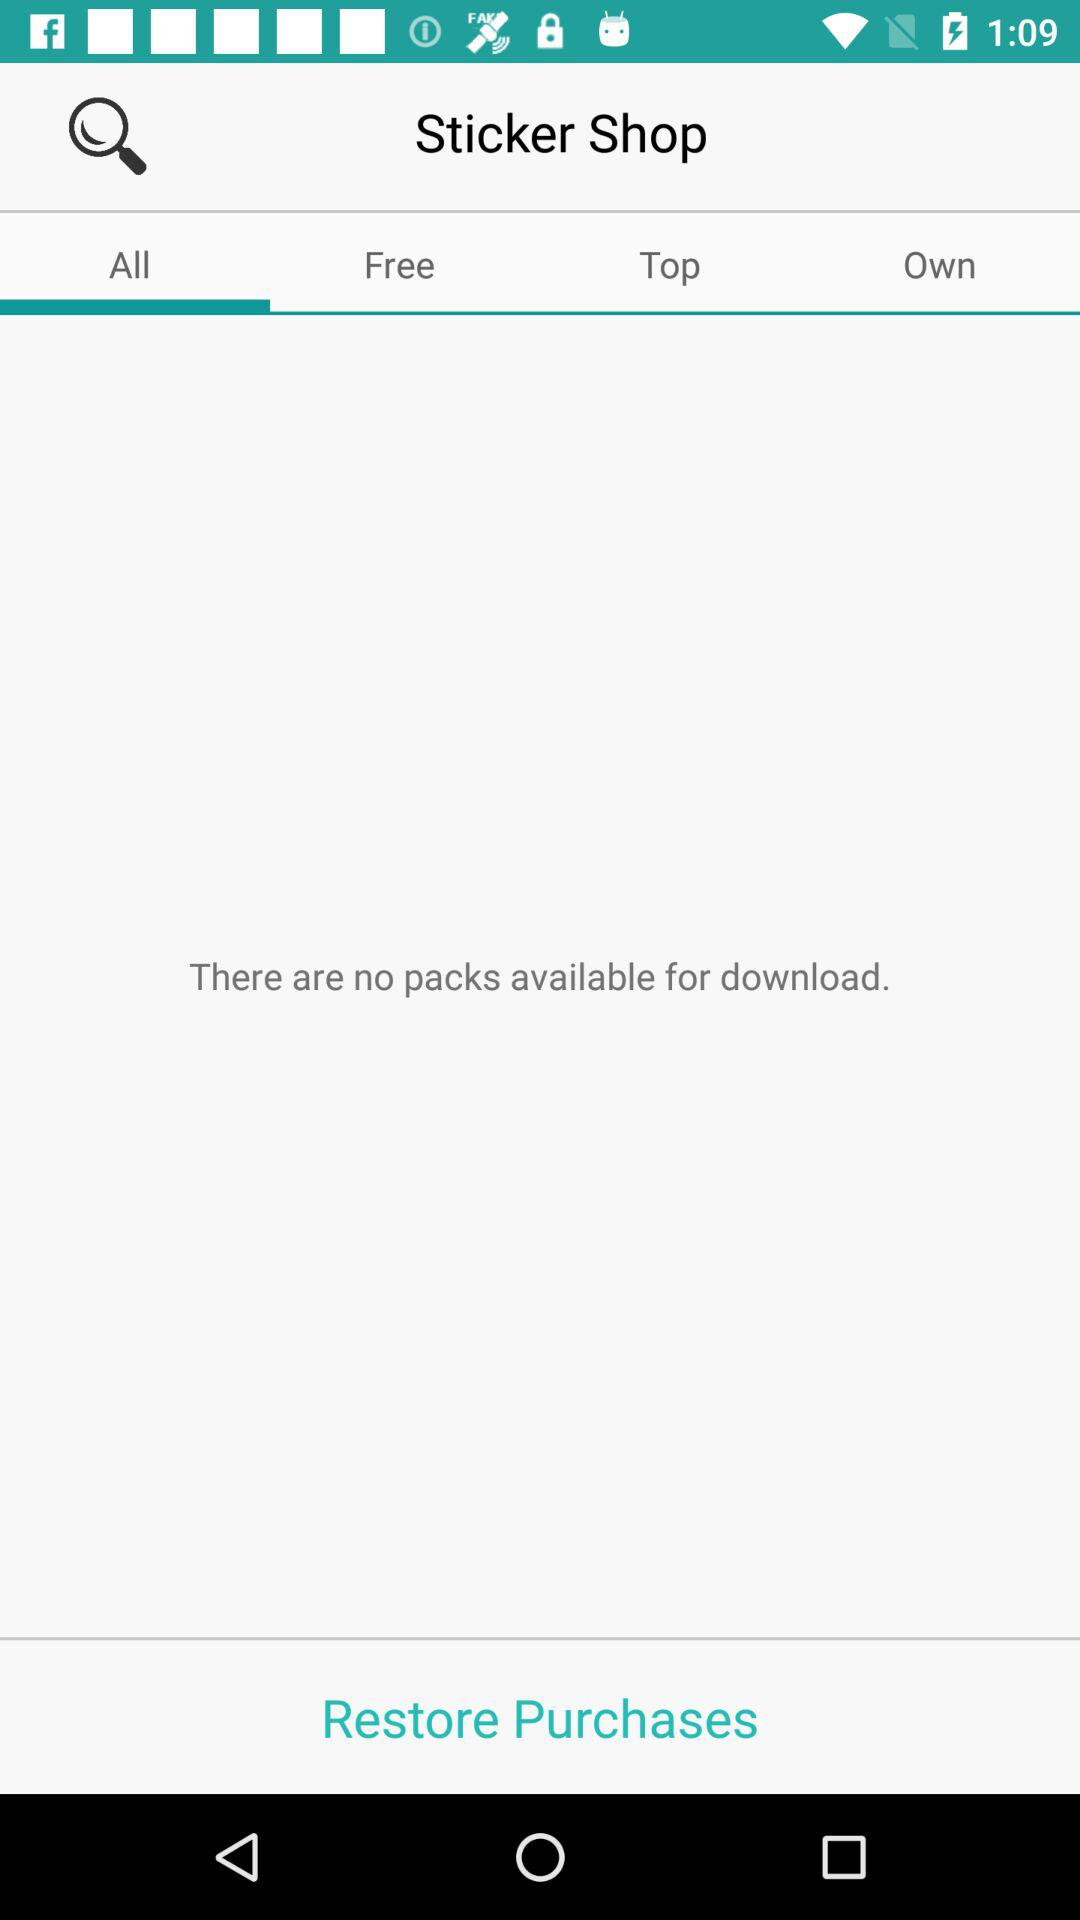What is the selected tab? The selected tab is "All". 